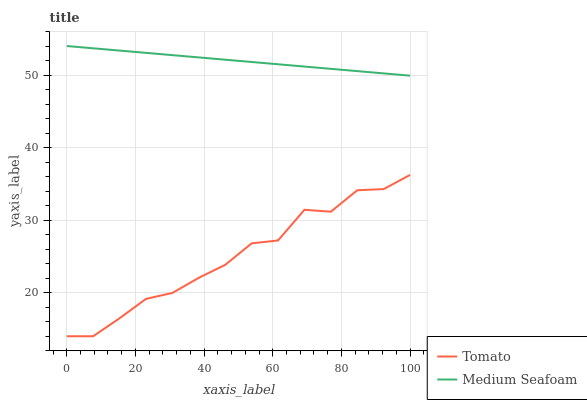Does Tomato have the minimum area under the curve?
Answer yes or no. Yes. Does Medium Seafoam have the maximum area under the curve?
Answer yes or no. Yes. Does Medium Seafoam have the minimum area under the curve?
Answer yes or no. No. Is Medium Seafoam the smoothest?
Answer yes or no. Yes. Is Tomato the roughest?
Answer yes or no. Yes. Is Medium Seafoam the roughest?
Answer yes or no. No. Does Tomato have the lowest value?
Answer yes or no. Yes. Does Medium Seafoam have the lowest value?
Answer yes or no. No. Does Medium Seafoam have the highest value?
Answer yes or no. Yes. Is Tomato less than Medium Seafoam?
Answer yes or no. Yes. Is Medium Seafoam greater than Tomato?
Answer yes or no. Yes. Does Tomato intersect Medium Seafoam?
Answer yes or no. No. 